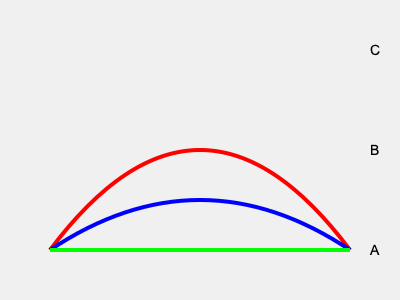Which of the stick designs shown above is most commonly used by British field hockey players in international competitions? To answer this question, we need to consider the characteristics of each stick design and their relevance to modern field hockey played at an international level:

1. Design A (Green line): This represents a completely straight stick. While historically used, straight sticks are now obsolete in modern field hockey due to their limited ball control and shooting power.

2. Design B (Blue curve): This shows a stick with a moderate curve. This design offers a good balance between control and power, allowing players to perform various techniques effectively.

3. Design C (Red curve): This depicts a stick with an extreme curve. While it might provide excellent ball control for certain skills, such extreme curves are typically not allowed in official competitions due to regulations on stick shapes.

British field hockey players, known for their technical skills and adherence to international regulations, would most likely use a stick similar to Design B in international competitions. This design provides the optimal balance of control, power, and legality required for high-level play.

Moreover, the governing body of field hockey, the International Hockey Federation (FIH), has specific rules about stick shapes. These rules generally allow for moderate curves that align more closely with Design B rather than the extreme curve of Design C or the straight Design A.
Answer: Design B (Blue curve) 